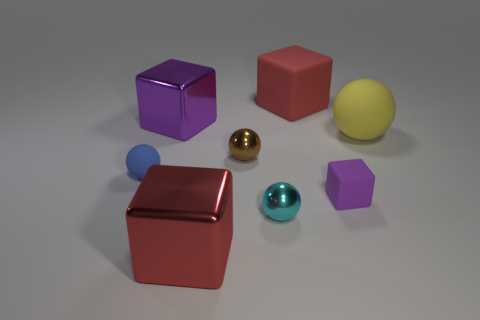Subtract all green spheres. Subtract all red cylinders. How many spheres are left? 4 Add 2 red blocks. How many objects exist? 10 Add 7 purple metal cubes. How many purple metal cubes are left? 8 Add 7 small brown matte blocks. How many small brown matte blocks exist? 7 Subtract 2 purple blocks. How many objects are left? 6 Subtract all small blue balls. Subtract all big red matte cubes. How many objects are left? 6 